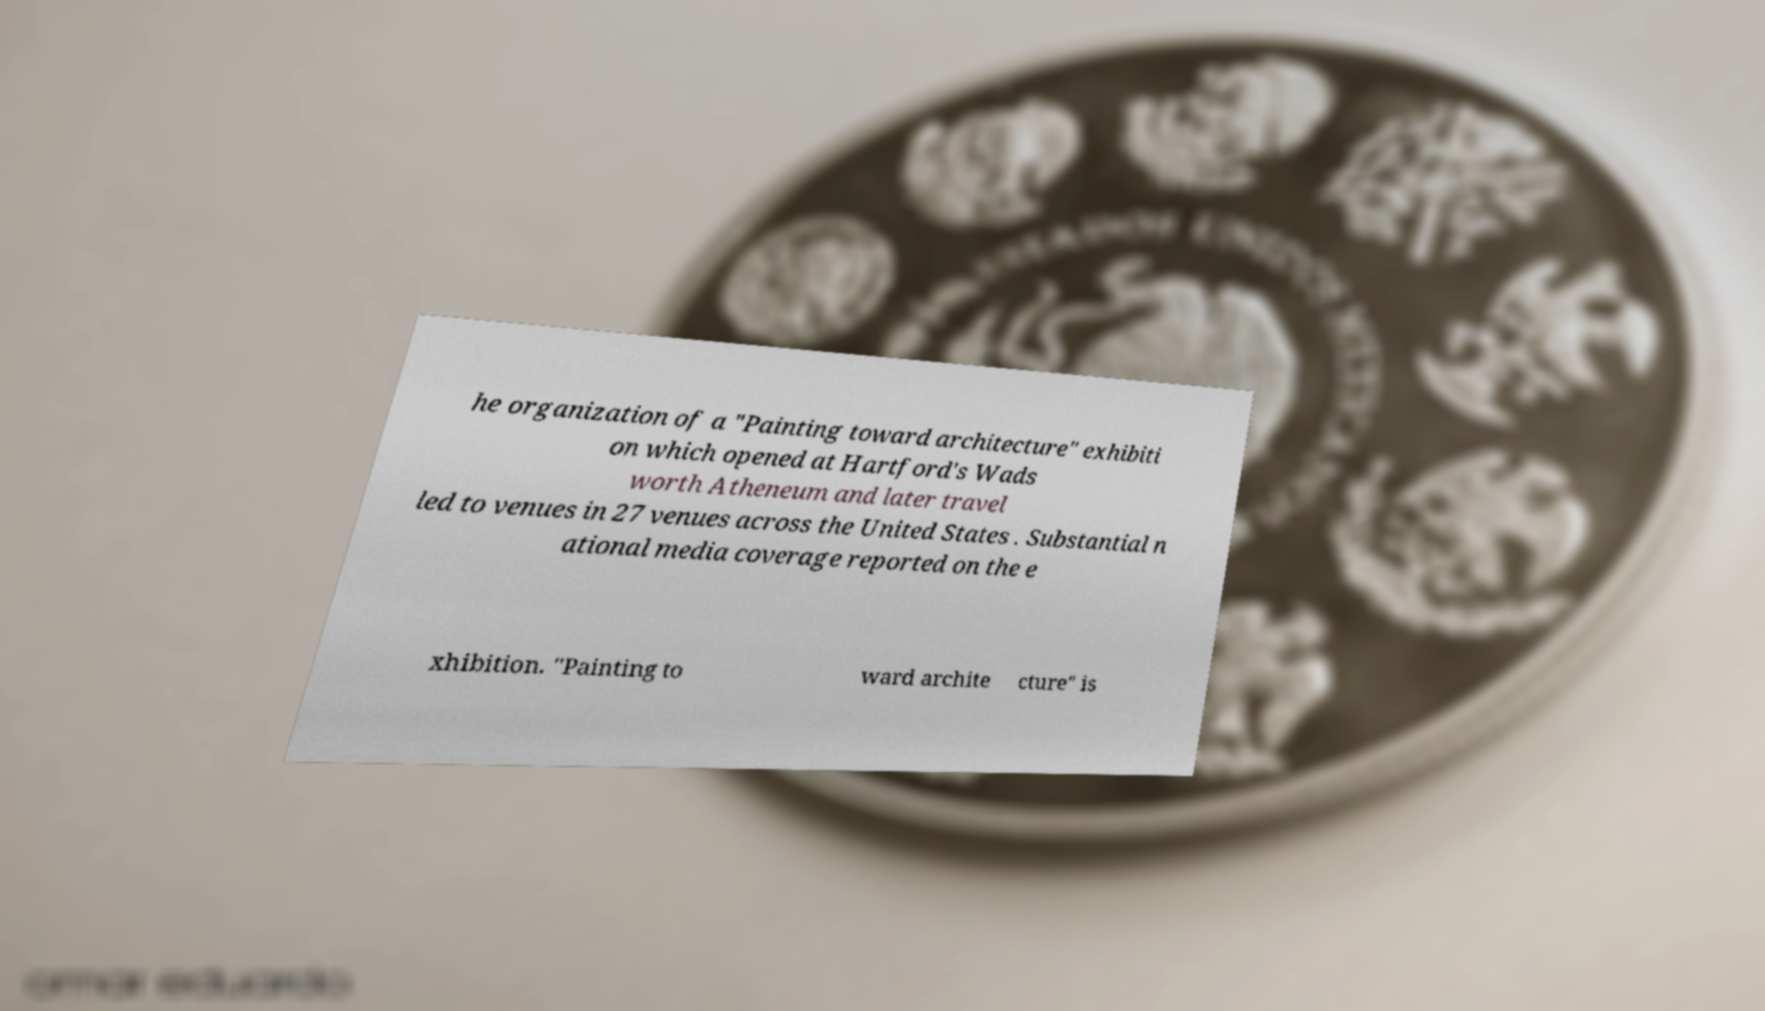Please read and relay the text visible in this image. What does it say? he organization of a "Painting toward architecture" exhibiti on which opened at Hartford's Wads worth Atheneum and later travel led to venues in 27 venues across the United States . Substantial n ational media coverage reported on the e xhibition. "Painting to ward archite cture" is 